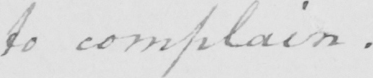Please transcribe the handwritten text in this image. to complain . 